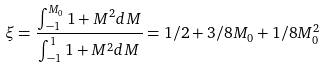<formula> <loc_0><loc_0><loc_500><loc_500>\xi = \frac { \int _ { - 1 } ^ { M _ { 0 } } 1 + M ^ { 2 } d M } { \int _ { - 1 } ^ { 1 } 1 + M ^ { 2 } d M } = 1 / 2 + 3 / 8 M _ { 0 } + 1 / 8 M _ { 0 } ^ { 2 }</formula> 